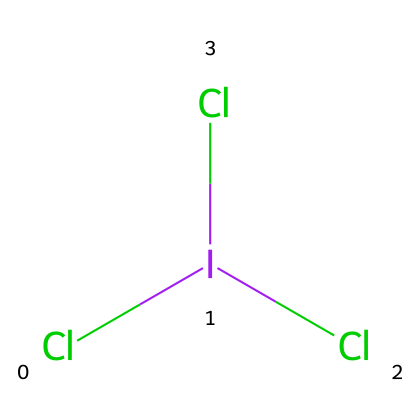What is the total number of chlorine atoms in iodine trichloride? The chemical structure shows three chlorine atoms (Cl), denoted by their symbols attached to the iodine atom (I).
Answer: three What type of compound is iodine trichloride? The structure contains iodine bonded to multiple chlorines, which indicates it is a hypervalent compound, characterized by having more than eight electrons in its valence shell.
Answer: hypervalent How many chemical bonds are present in iodine trichloride? There are three bonds between iodine (I) and the three chlorine atoms (Cl), represented visually in the structure as connections in the SMILES notation.
Answer: three What is the central atom in the molecular structure of iodine trichloride? In the SMILES representation, iodine (I) is positioned at the center with three chlorine atoms bonded to it, making it the central atom.
Answer: iodine Does iodine trichloride exceed the octet rule? Yes, iodine (I) is surrounded by more than eight electrons due to its three bonds with chlorine atoms. This means it is a typical example of a hypervalent compound that exceeds the octet rule.
Answer: yes 